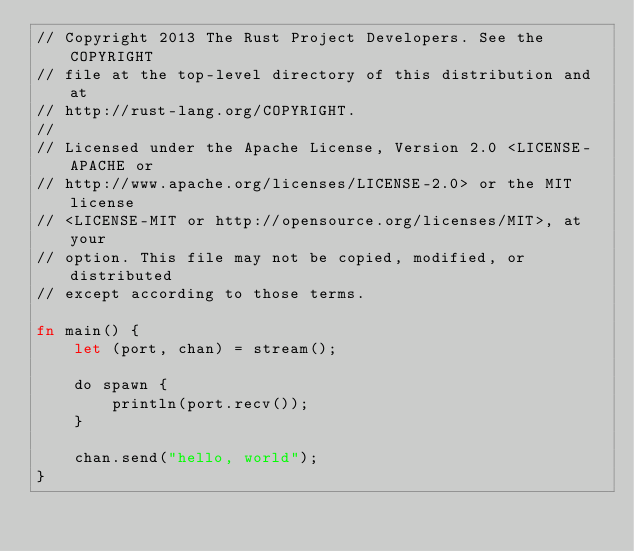Convert code to text. <code><loc_0><loc_0><loc_500><loc_500><_Rust_>// Copyright 2013 The Rust Project Developers. See the COPYRIGHT
// file at the top-level directory of this distribution and at
// http://rust-lang.org/COPYRIGHT.
//
// Licensed under the Apache License, Version 2.0 <LICENSE-APACHE or
// http://www.apache.org/licenses/LICENSE-2.0> or the MIT license
// <LICENSE-MIT or http://opensource.org/licenses/MIT>, at your
// option. This file may not be copied, modified, or distributed
// except according to those terms.

fn main() {
    let (port, chan) = stream();

    do spawn {
        println(port.recv());
    }

    chan.send("hello, world");
}
</code> 